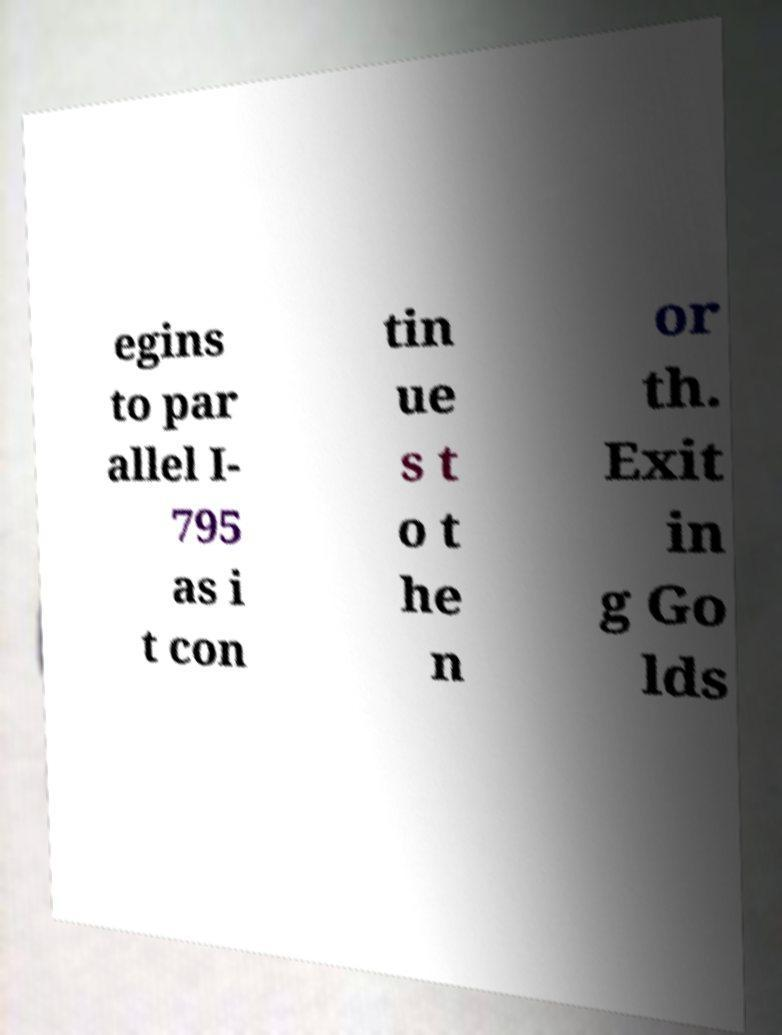Could you assist in decoding the text presented in this image and type it out clearly? egins to par allel I- 795 as i t con tin ue s t o t he n or th. Exit in g Go lds 